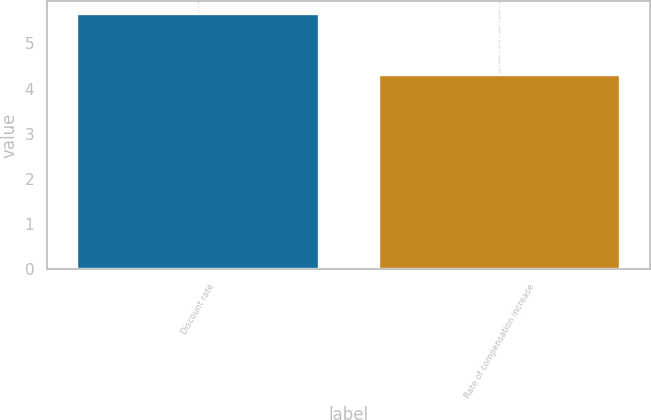Convert chart. <chart><loc_0><loc_0><loc_500><loc_500><bar_chart><fcel>Discount rate<fcel>Rate of compensation increase<nl><fcel>5.65<fcel>4.3<nl></chart> 